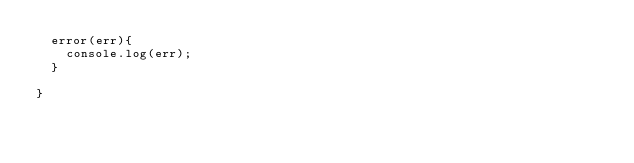<code> <loc_0><loc_0><loc_500><loc_500><_JavaScript_>	error(err){
		console.log(err);
	}

}</code> 